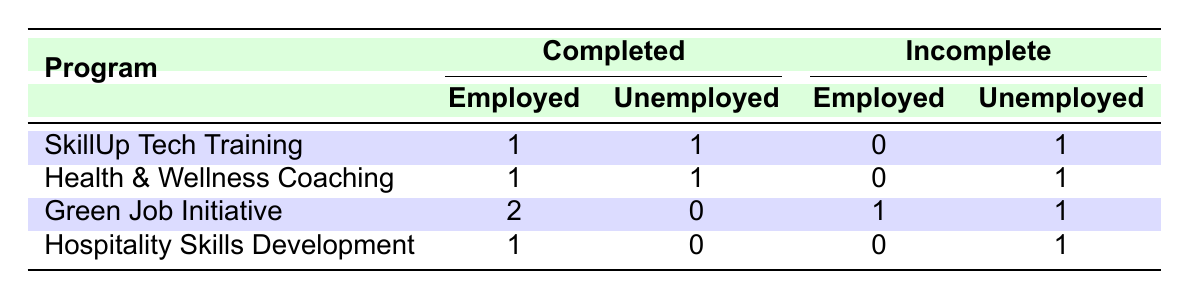What is the total number of individuals who completed the "SkillUp Tech Training"? In the table, under the "Completed" column for the "SkillUp Tech Training" program, there are 2 entries: one for "Employed" and one for "Unemployed". Thus, the total is 1 (Employed) + 1 (Unemployed) = 2.
Answer: 2 How many individuals from the "Green Job Initiative" ended up unemployed after training? In the table, under the "Incomplete" column for the "Green Job Initiative," there is 1 entry for "Unemployed". Thus, the total number of unemployed individuals from this program is 1.
Answer: 1 Did any individuals from the "Hospitality Skills Development" program gain employment after completing the program? There is 1 entry under the "Completed" column for "Employed" in the "Hospitality Skills Development" program, which indicates that at least one individual did gain employment after completing the program.
Answer: Yes What is the difference in the number of employed individuals between the "Green Job Initiative" and the "Health & Wellness Coaching"? From the table, the "Green Job Initiative" has 2 entries for "Employed," whereas the "Health & Wellness Coaching" has 1 entry for "Employed." Therefore, the difference is 2 - 1 = 1.
Answer: 1 If we take the total number of individuals who completed training programs and those who did not complete them, what is the overall ratio of completed to incomplete individuals? The total number of completed individuals is 4 (1 from "SkillUp Tech Training," 1 from "Health & Wellness Coaching," and 2 from "Green Job Initiative"). The total number of incomplete individuals is 3 (1 from "Green Job Initiative" and 2 from "Hospitality Skills Development"). The ratio of completed to incomplete is 4 to 3, which can also be expressed as 4:3.
Answer: 4:3 How many total individuals became employed after completing all training programs? Summing up all employed entries across completed programs, there are 1 from "SkillUp Tech Training," 1 from "Health & Wellness Coaching," and 2 from "Green Job Initiative," resulting in a total of 4 employed individuals after completing the programs (1 + 1 + 2 = 4).
Answer: 4 What proportion of individuals who completed the "Health & Wellness Coaching" program ended up unemployed? There are 2 individuals from the "Health & Wellness Coaching" program, 1 employed and 1 unemployed. The proportion of unemployed individuals is 1 (Unemployed) out of 2 (Total), which equals 1/2 or 50%.
Answer: 50% How many programs had more unemployed individuals post-training than employed individuals? Looking at the table, both "SkillUp Tech Training" and "Health & Wellness Coaching" had 1 unemployed and 1 employed. The "Hospitality Skills Development" had 1 unemployed and 1 employed as well. However, only "Green Job Initiative" lists 2 employed and 0 unemployed, along with 1 unemployed in "Incomplete." Thus, no program had more unemployed than employed individuals after completion.
Answer: None 